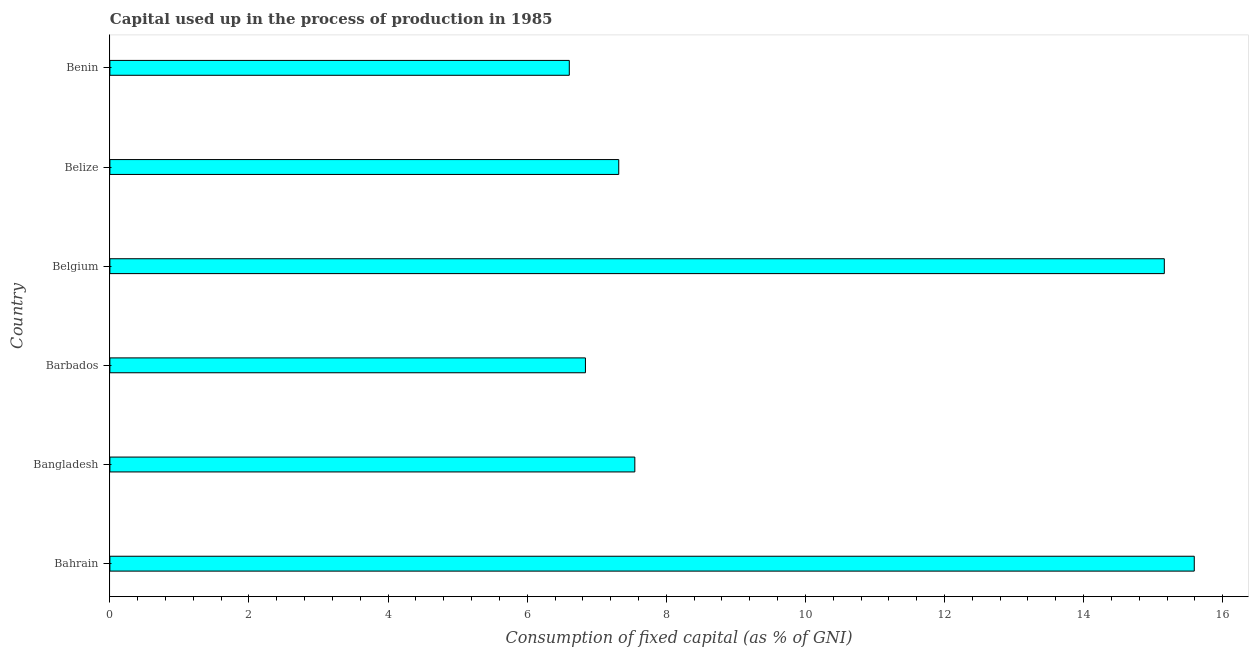Does the graph contain grids?
Your response must be concise. No. What is the title of the graph?
Your answer should be very brief. Capital used up in the process of production in 1985. What is the label or title of the X-axis?
Offer a very short reply. Consumption of fixed capital (as % of GNI). What is the consumption of fixed capital in Barbados?
Your answer should be very brief. 6.84. Across all countries, what is the maximum consumption of fixed capital?
Make the answer very short. 15.59. Across all countries, what is the minimum consumption of fixed capital?
Give a very brief answer. 6.61. In which country was the consumption of fixed capital maximum?
Give a very brief answer. Bahrain. In which country was the consumption of fixed capital minimum?
Give a very brief answer. Benin. What is the sum of the consumption of fixed capital?
Offer a very short reply. 59.06. What is the difference between the consumption of fixed capital in Bangladesh and Belgium?
Give a very brief answer. -7.61. What is the average consumption of fixed capital per country?
Keep it short and to the point. 9.84. What is the median consumption of fixed capital?
Your response must be concise. 7.43. What is the ratio of the consumption of fixed capital in Barbados to that in Belgium?
Make the answer very short. 0.45. Is the consumption of fixed capital in Bangladesh less than that in Benin?
Your response must be concise. No. Is the difference between the consumption of fixed capital in Belgium and Benin greater than the difference between any two countries?
Offer a very short reply. No. What is the difference between the highest and the second highest consumption of fixed capital?
Provide a succinct answer. 0.43. What is the difference between the highest and the lowest consumption of fixed capital?
Ensure brevity in your answer.  8.99. In how many countries, is the consumption of fixed capital greater than the average consumption of fixed capital taken over all countries?
Your answer should be compact. 2. Are the values on the major ticks of X-axis written in scientific E-notation?
Your answer should be compact. No. What is the Consumption of fixed capital (as % of GNI) in Bahrain?
Make the answer very short. 15.59. What is the Consumption of fixed capital (as % of GNI) of Bangladesh?
Make the answer very short. 7.55. What is the Consumption of fixed capital (as % of GNI) of Barbados?
Provide a succinct answer. 6.84. What is the Consumption of fixed capital (as % of GNI) of Belgium?
Your response must be concise. 15.16. What is the Consumption of fixed capital (as % of GNI) of Belize?
Keep it short and to the point. 7.32. What is the Consumption of fixed capital (as % of GNI) of Benin?
Offer a terse response. 6.61. What is the difference between the Consumption of fixed capital (as % of GNI) in Bahrain and Bangladesh?
Your answer should be very brief. 8.04. What is the difference between the Consumption of fixed capital (as % of GNI) in Bahrain and Barbados?
Your answer should be compact. 8.75. What is the difference between the Consumption of fixed capital (as % of GNI) in Bahrain and Belgium?
Your answer should be compact. 0.43. What is the difference between the Consumption of fixed capital (as % of GNI) in Bahrain and Belize?
Your response must be concise. 8.28. What is the difference between the Consumption of fixed capital (as % of GNI) in Bahrain and Benin?
Your response must be concise. 8.99. What is the difference between the Consumption of fixed capital (as % of GNI) in Bangladesh and Barbados?
Make the answer very short. 0.71. What is the difference between the Consumption of fixed capital (as % of GNI) in Bangladesh and Belgium?
Keep it short and to the point. -7.61. What is the difference between the Consumption of fixed capital (as % of GNI) in Bangladesh and Belize?
Provide a succinct answer. 0.23. What is the difference between the Consumption of fixed capital (as % of GNI) in Bangladesh and Benin?
Offer a terse response. 0.94. What is the difference between the Consumption of fixed capital (as % of GNI) in Barbados and Belgium?
Your answer should be very brief. -8.32. What is the difference between the Consumption of fixed capital (as % of GNI) in Barbados and Belize?
Provide a short and direct response. -0.48. What is the difference between the Consumption of fixed capital (as % of GNI) in Barbados and Benin?
Provide a short and direct response. 0.23. What is the difference between the Consumption of fixed capital (as % of GNI) in Belgium and Belize?
Make the answer very short. 7.84. What is the difference between the Consumption of fixed capital (as % of GNI) in Belgium and Benin?
Keep it short and to the point. 8.56. What is the difference between the Consumption of fixed capital (as % of GNI) in Belize and Benin?
Your response must be concise. 0.71. What is the ratio of the Consumption of fixed capital (as % of GNI) in Bahrain to that in Bangladesh?
Your answer should be very brief. 2.07. What is the ratio of the Consumption of fixed capital (as % of GNI) in Bahrain to that in Barbados?
Provide a succinct answer. 2.28. What is the ratio of the Consumption of fixed capital (as % of GNI) in Bahrain to that in Belgium?
Your answer should be very brief. 1.03. What is the ratio of the Consumption of fixed capital (as % of GNI) in Bahrain to that in Belize?
Ensure brevity in your answer.  2.13. What is the ratio of the Consumption of fixed capital (as % of GNI) in Bahrain to that in Benin?
Ensure brevity in your answer.  2.36. What is the ratio of the Consumption of fixed capital (as % of GNI) in Bangladesh to that in Barbados?
Provide a short and direct response. 1.1. What is the ratio of the Consumption of fixed capital (as % of GNI) in Bangladesh to that in Belgium?
Your answer should be compact. 0.5. What is the ratio of the Consumption of fixed capital (as % of GNI) in Bangladesh to that in Belize?
Make the answer very short. 1.03. What is the ratio of the Consumption of fixed capital (as % of GNI) in Bangladesh to that in Benin?
Offer a terse response. 1.14. What is the ratio of the Consumption of fixed capital (as % of GNI) in Barbados to that in Belgium?
Give a very brief answer. 0.45. What is the ratio of the Consumption of fixed capital (as % of GNI) in Barbados to that in Belize?
Your answer should be very brief. 0.94. What is the ratio of the Consumption of fixed capital (as % of GNI) in Barbados to that in Benin?
Offer a terse response. 1.03. What is the ratio of the Consumption of fixed capital (as % of GNI) in Belgium to that in Belize?
Your answer should be very brief. 2.07. What is the ratio of the Consumption of fixed capital (as % of GNI) in Belgium to that in Benin?
Make the answer very short. 2.29. What is the ratio of the Consumption of fixed capital (as % of GNI) in Belize to that in Benin?
Your answer should be compact. 1.11. 